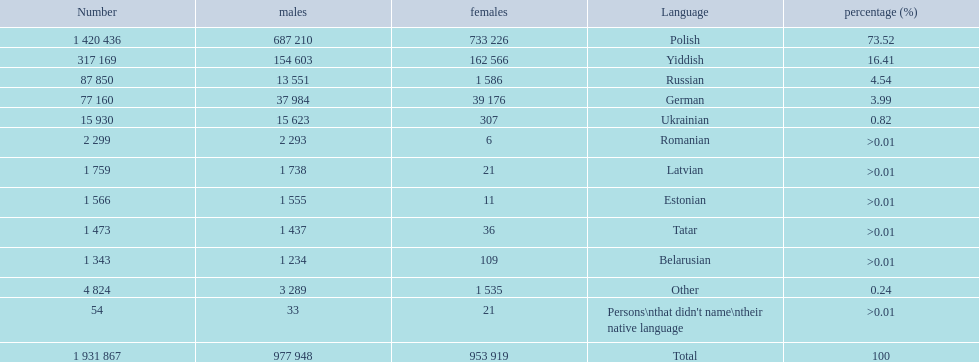What are all of the languages Polish, Yiddish, Russian, German, Ukrainian, Romanian, Latvian, Estonian, Tatar, Belarusian, Other, Persons\nthat didn't name\ntheir native language. What was the percentage of each? 73.52, 16.41, 4.54, 3.99, 0.82, >0.01, >0.01, >0.01, >0.01, >0.01, 0.24, >0.01. Which languages had a >0.01	 percentage? Romanian, Latvian, Estonian, Tatar, Belarusian. And of those, which is listed first? Romanian. 